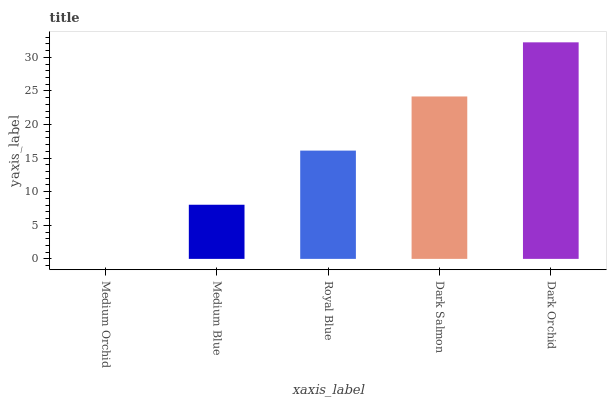Is Medium Orchid the minimum?
Answer yes or no. Yes. Is Dark Orchid the maximum?
Answer yes or no. Yes. Is Medium Blue the minimum?
Answer yes or no. No. Is Medium Blue the maximum?
Answer yes or no. No. Is Medium Blue greater than Medium Orchid?
Answer yes or no. Yes. Is Medium Orchid less than Medium Blue?
Answer yes or no. Yes. Is Medium Orchid greater than Medium Blue?
Answer yes or no. No. Is Medium Blue less than Medium Orchid?
Answer yes or no. No. Is Royal Blue the high median?
Answer yes or no. Yes. Is Royal Blue the low median?
Answer yes or no. Yes. Is Dark Orchid the high median?
Answer yes or no. No. Is Medium Orchid the low median?
Answer yes or no. No. 